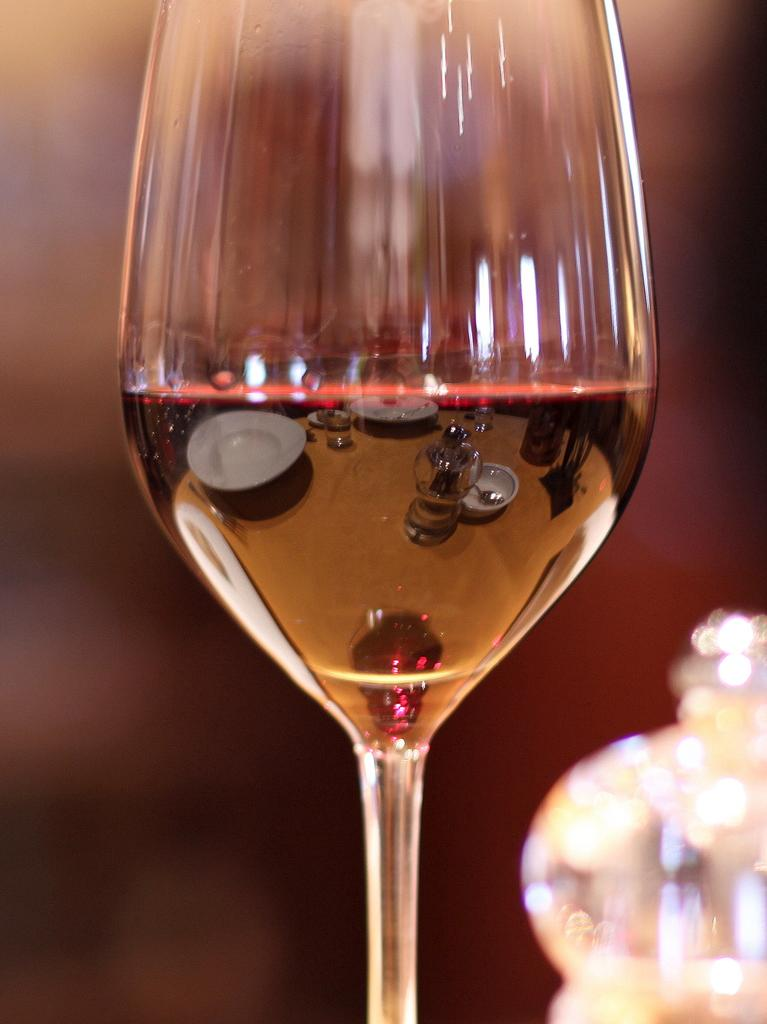What is the main object in the center of the image? There is a glass in the center of the image. Is the glass sinking into the quicksand in the image? There is no quicksand present in the image, so the glass cannot be sinking into it. 